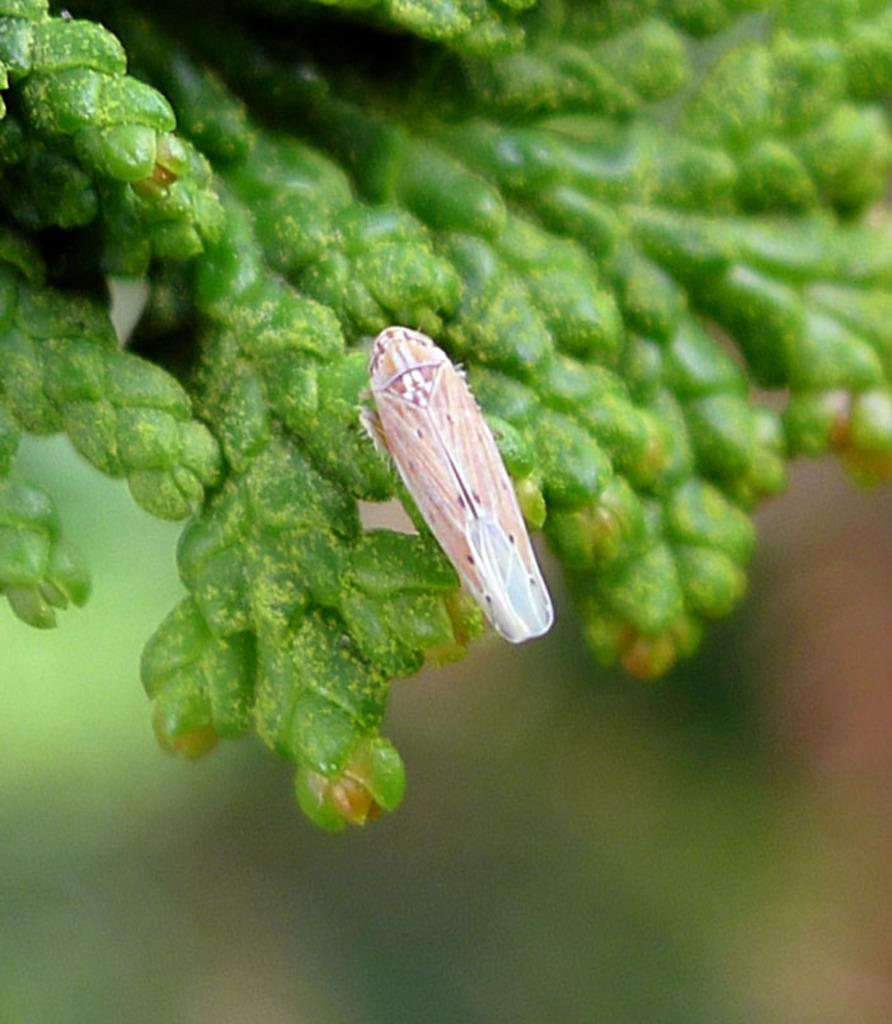What type of plant is depicted in the image? The image shows buds of a plant. Can you describe any other living organism present in the image? Yes, there is an insect on the buds in the image. What type of fiction is the insect reading on the buds in the image? There is no indication in the image that the insect is reading any fiction, as insects do not read. 